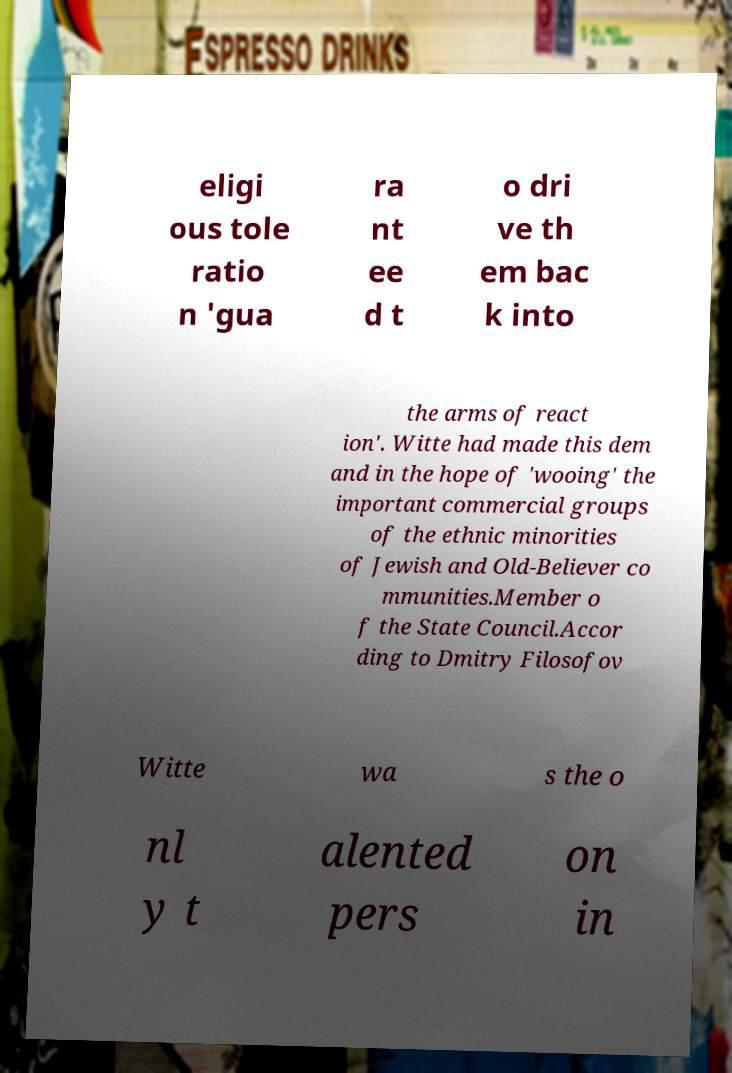For documentation purposes, I need the text within this image transcribed. Could you provide that? eligi ous tole ratio n 'gua ra nt ee d t o dri ve th em bac k into the arms of react ion'. Witte had made this dem and in the hope of 'wooing' the important commercial groups of the ethnic minorities of Jewish and Old-Believer co mmunities.Member o f the State Council.Accor ding to Dmitry Filosofov Witte wa s the o nl y t alented pers on in 